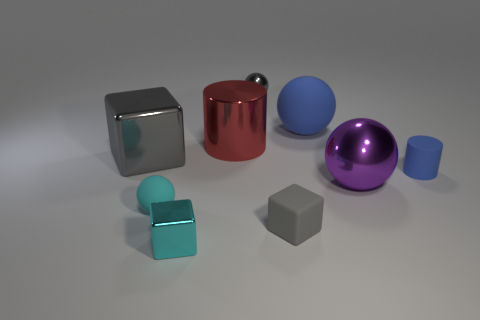Subtract all tiny blocks. How many blocks are left? 1 Subtract all purple balls. How many balls are left? 3 Add 1 small purple balls. How many objects exist? 10 Subtract all red spheres. Subtract all red cylinders. How many spheres are left? 4 Add 7 small red metal objects. How many small red metal objects exist? 7 Subtract 1 gray balls. How many objects are left? 8 Subtract all balls. How many objects are left? 5 Subtract all big brown things. Subtract all tiny gray blocks. How many objects are left? 8 Add 7 cyan matte objects. How many cyan matte objects are left? 8 